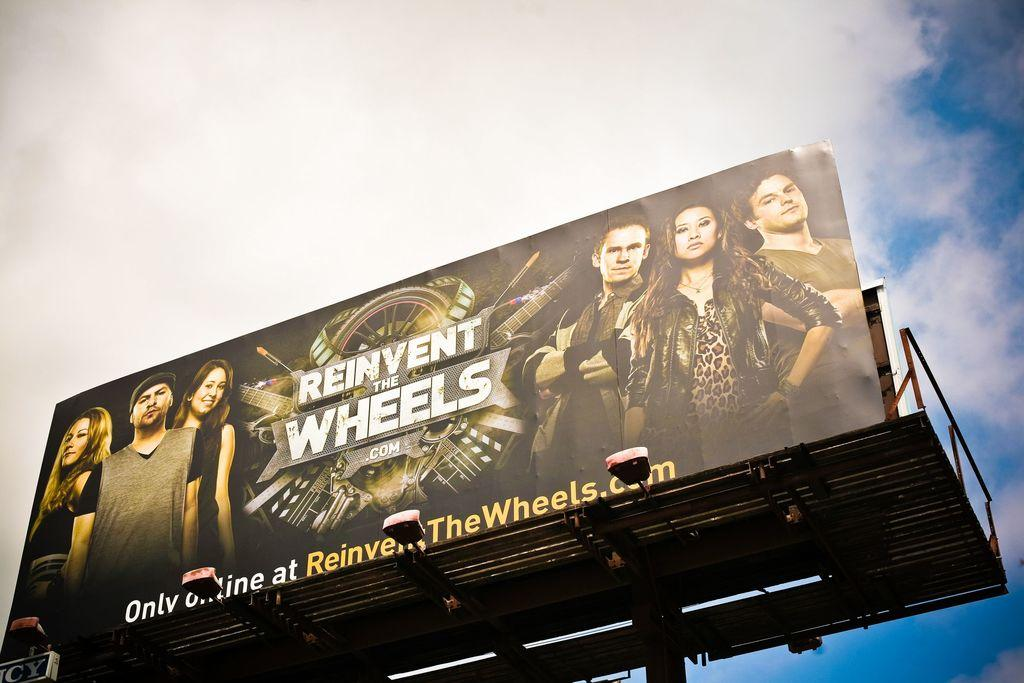<image>
Share a concise interpretation of the image provided. Billboard for REINVENT WHEELS high up against a blue sky 